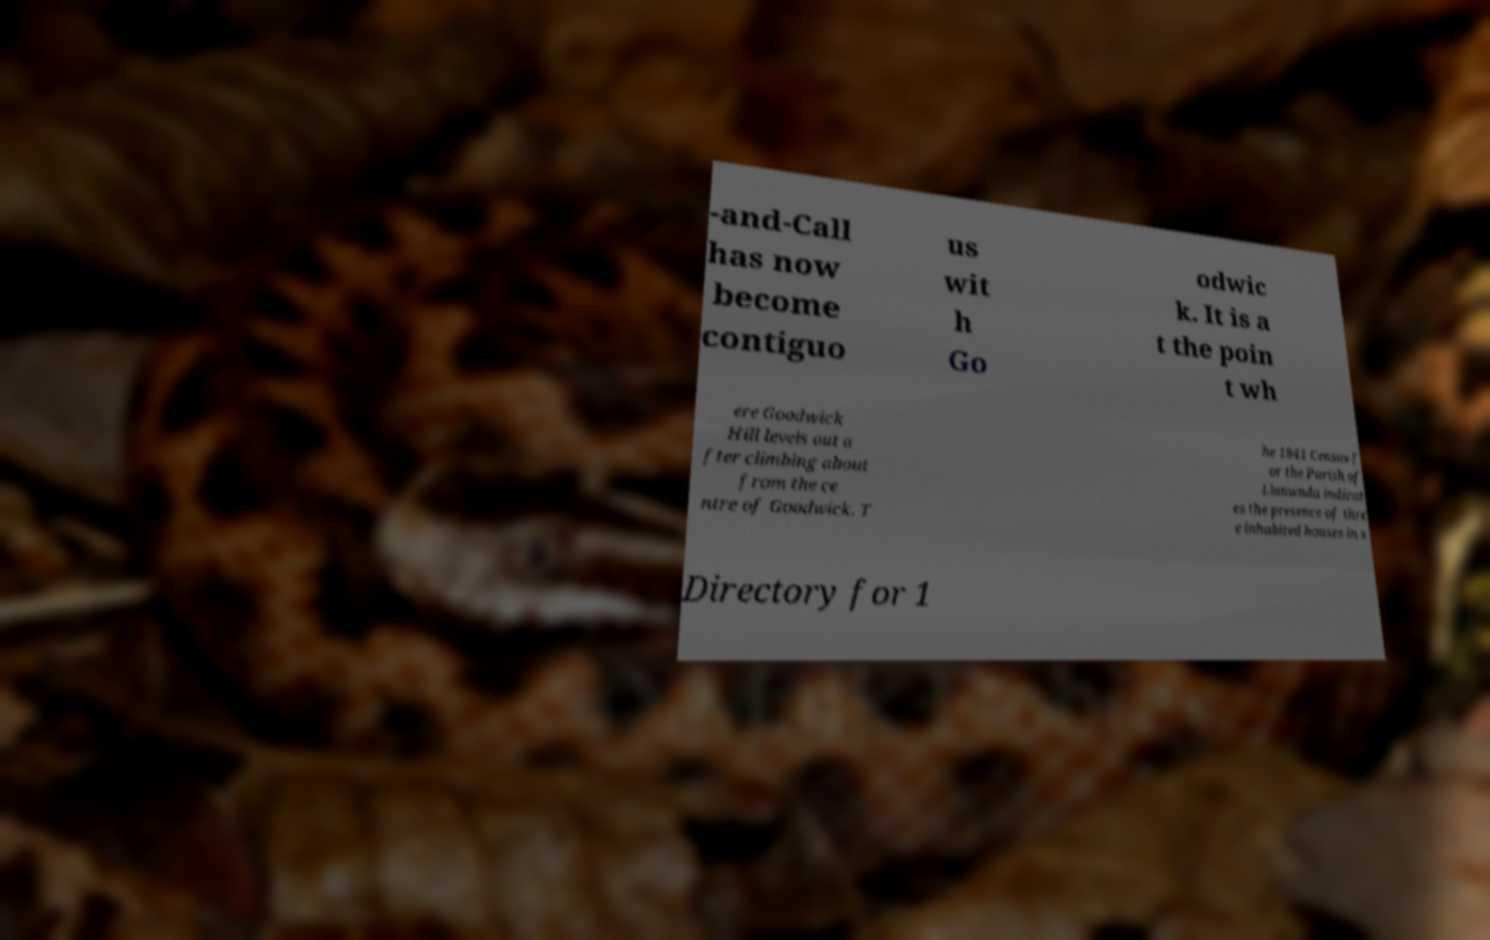Can you accurately transcribe the text from the provided image for me? -and-Call has now become contiguo us wit h Go odwic k. It is a t the poin t wh ere Goodwick Hill levels out a fter climbing about from the ce ntre of Goodwick. T he 1841 Census f or the Parish of Llanwnda indicat es the presence of thre e inhabited houses in s Directory for 1 